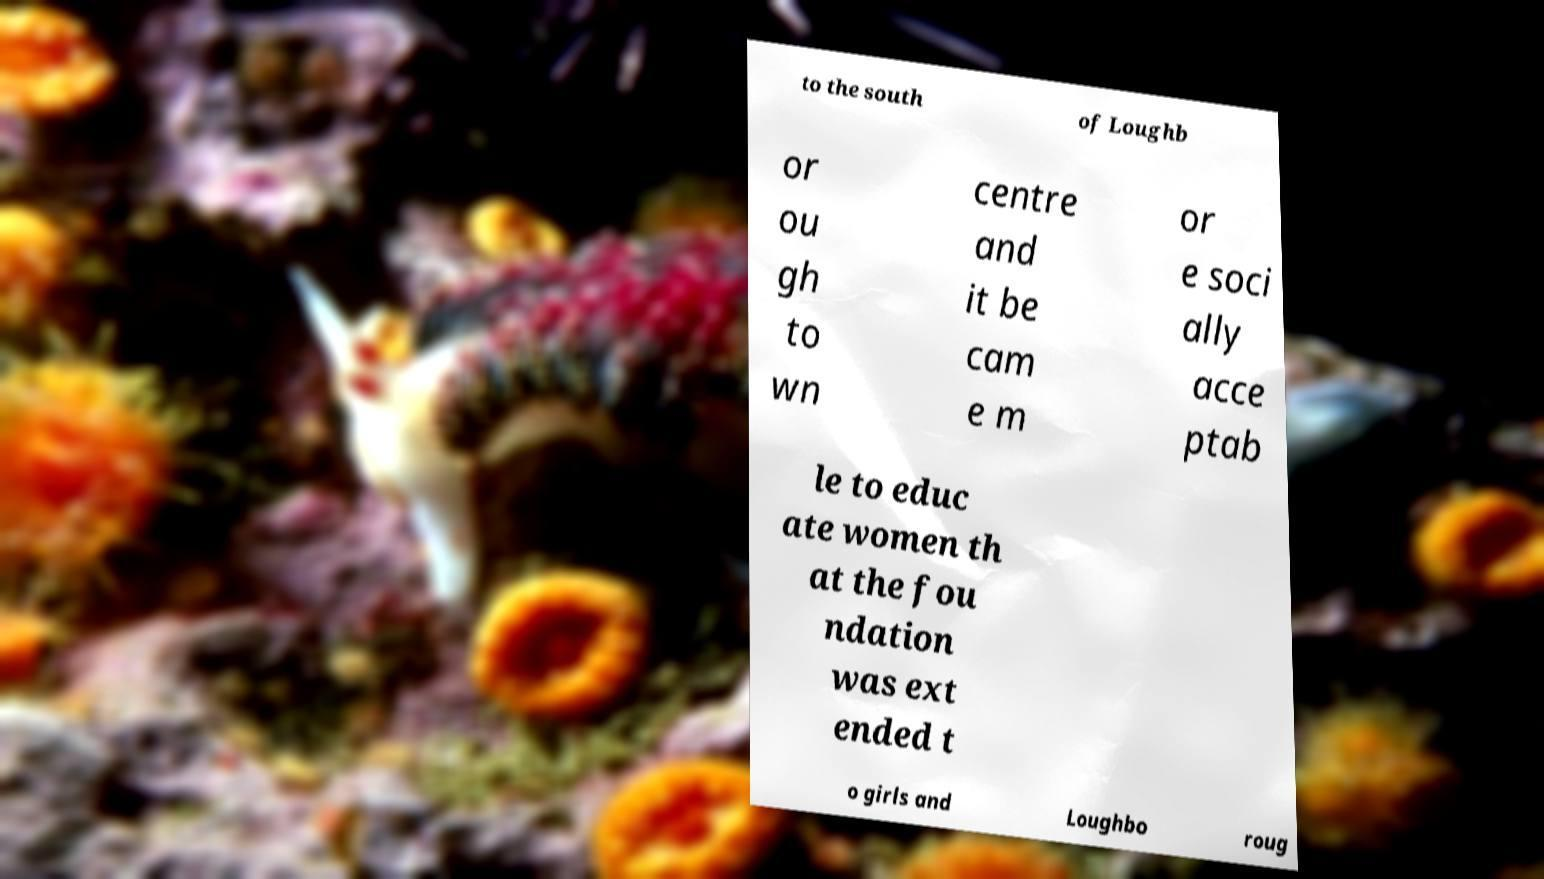Can you accurately transcribe the text from the provided image for me? to the south of Loughb or ou gh to wn centre and it be cam e m or e soci ally acce ptab le to educ ate women th at the fou ndation was ext ended t o girls and Loughbo roug 